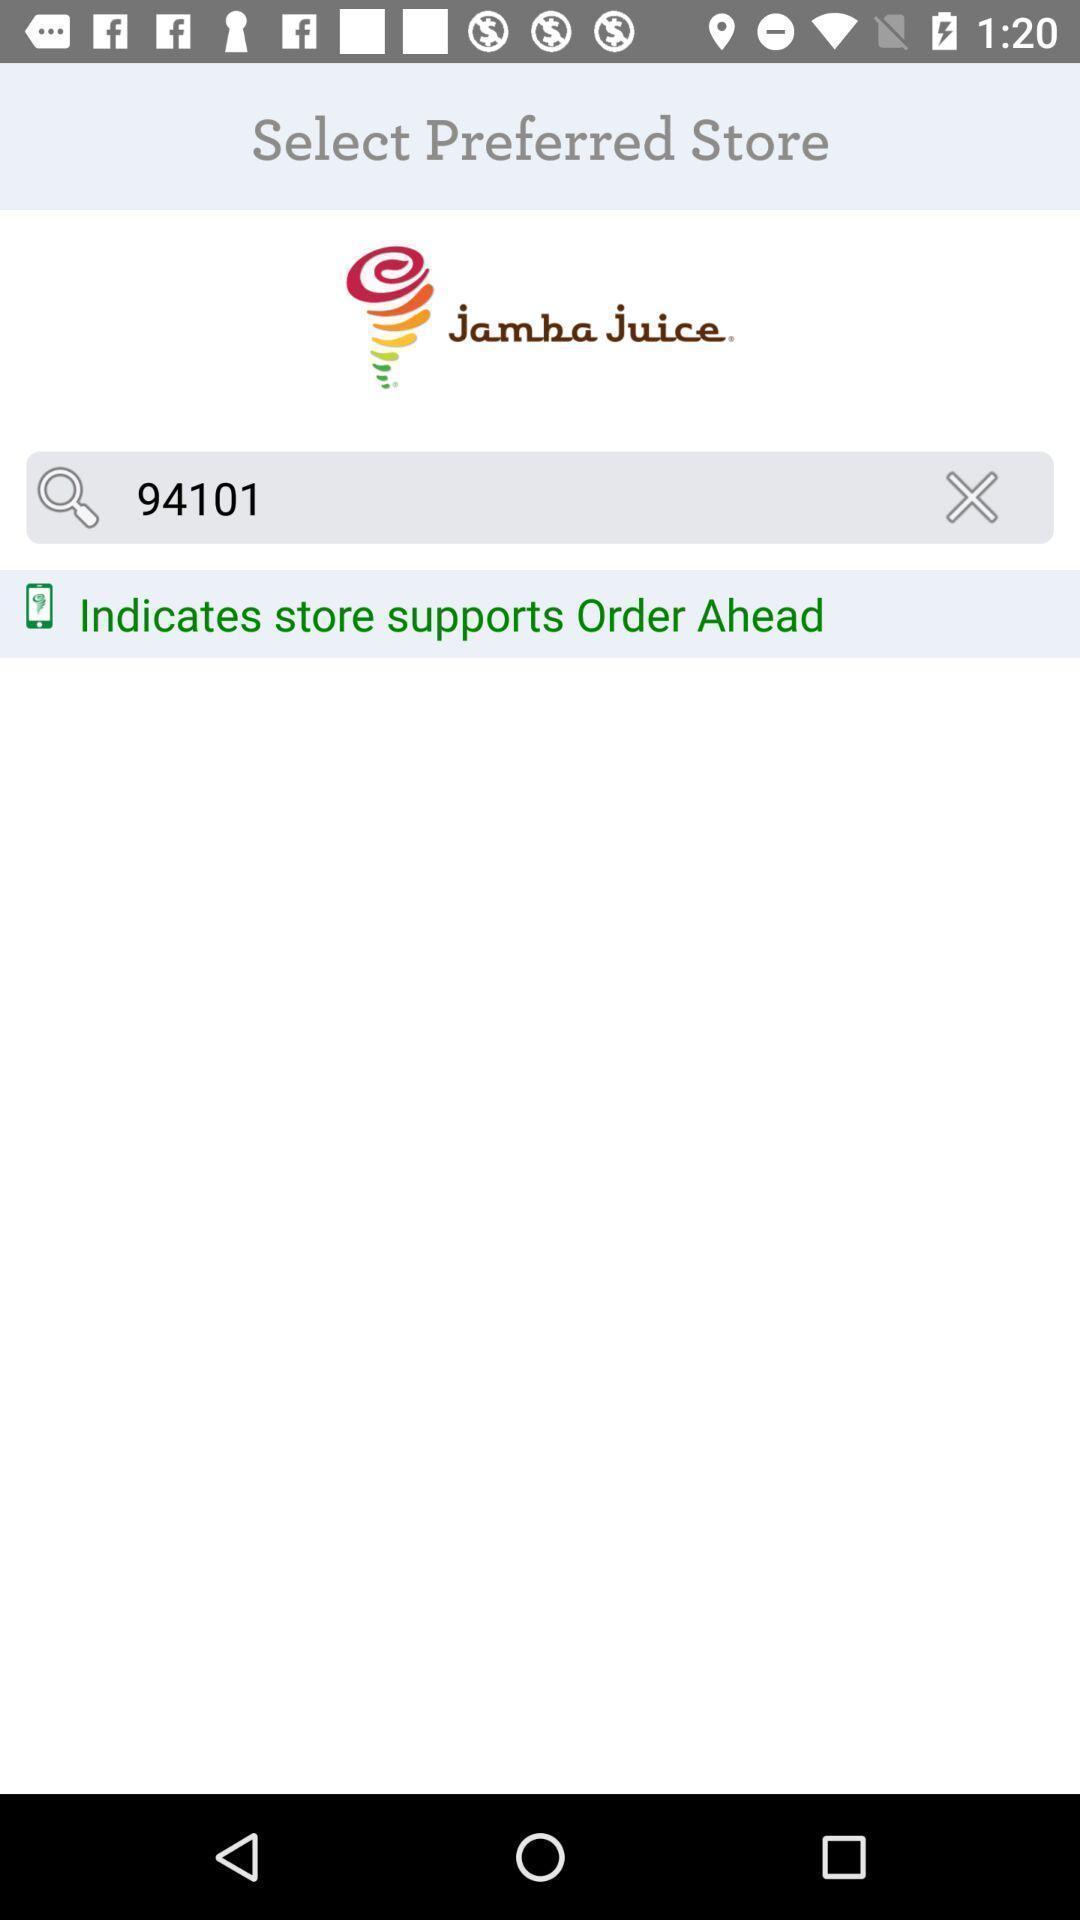Describe the content in this image. Search bar to find the address of store in application. 